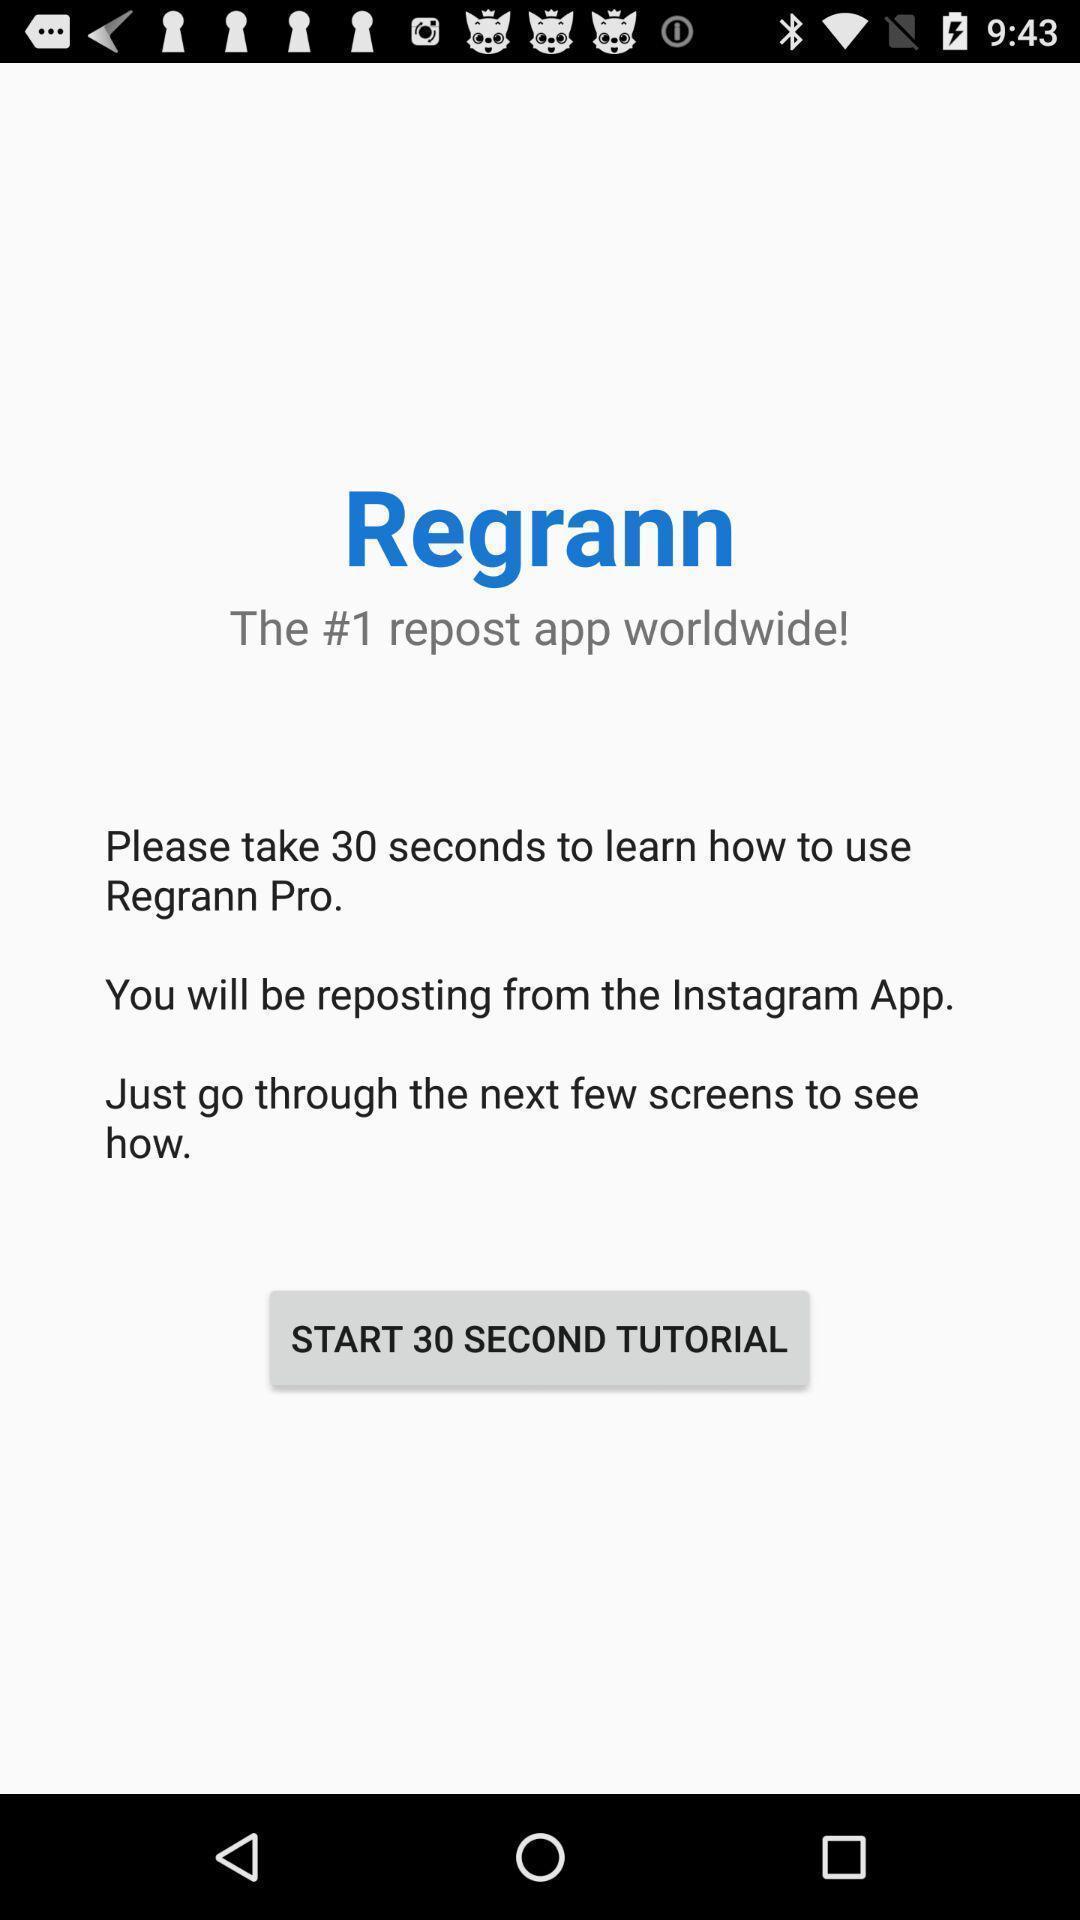Describe the content in this image. Welcome screen of social networking app with tutorial. 